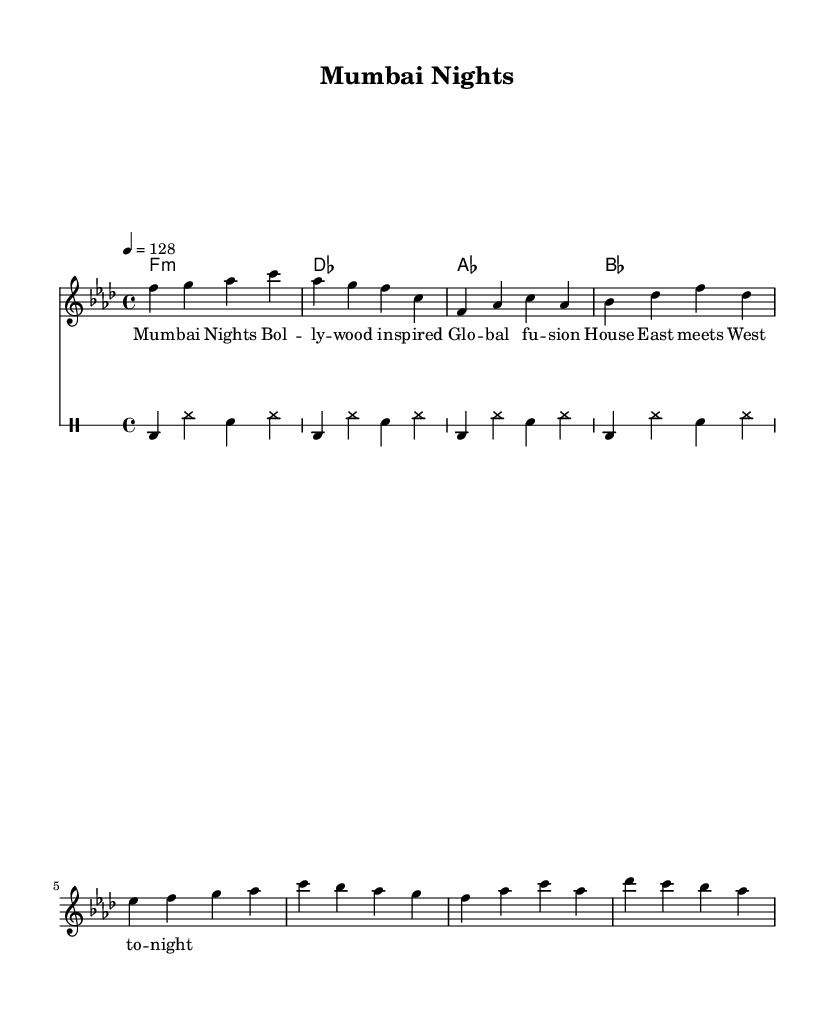What is the key signature of this music? The key signature is F minor, which contains four flats (B♭, E♭, A♭, and D♭).
Answer: F minor What is the time signature of this music? The time signature is 4/4, indicating that there are four beats in each measure and the quarter note gets one beat.
Answer: 4/4 What is the tempo of this music? The tempo is marked as 128 beats per minute, indicating a moderate pace suitable for dance tracks.
Answer: 128 How many measures are in the melody section? Counting the measures in the melody shows there are a total of six measures present.
Answer: 6 What is the first chord in the harmony section? The first chord is F minor, indicated at the start of the chord progression.
Answer: F minor How many times is the bass drum played in the drum section? The bass drum is played once in every measure during the repeated pattern, which appears four times, leading to a total of four hits.
Answer: 4 What kind of musical fusion is represented in this piece? This piece integrates elements from Bollywood music, showcasing traditional Indian vocal styles and rhythms within a house music framework.
Answer: Global fusion House 